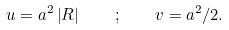Convert formula to latex. <formula><loc_0><loc_0><loc_500><loc_500>u = a ^ { 2 } \left | R \right | \quad ; \quad v = a ^ { 2 } / 2 .</formula> 